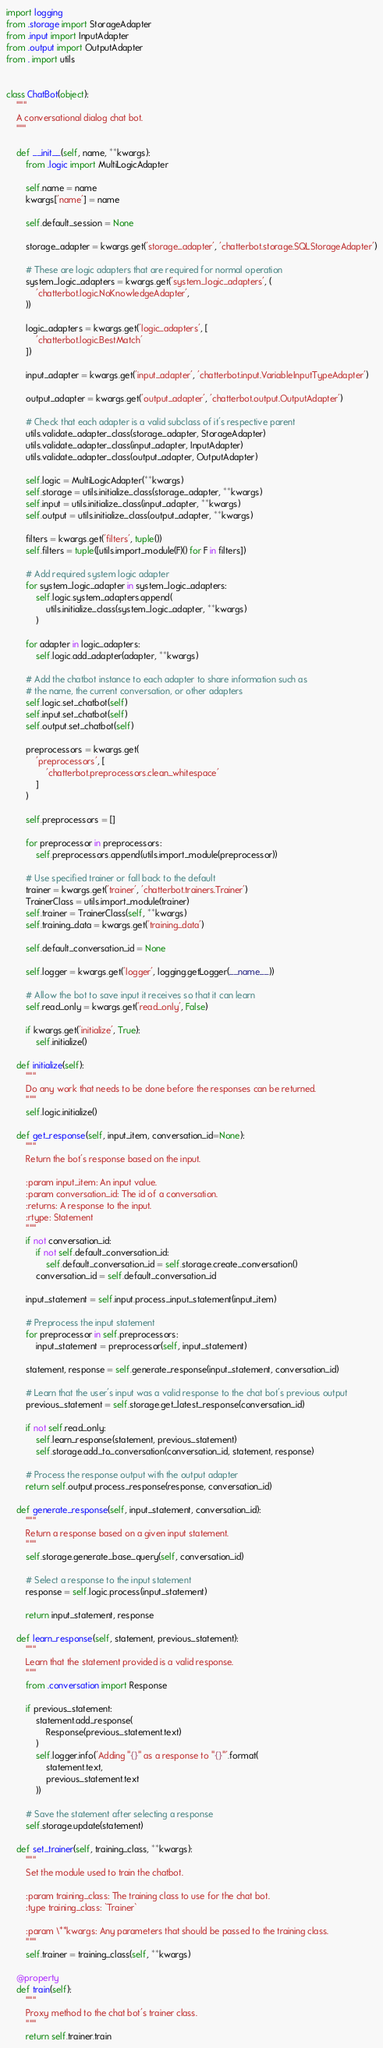Convert code to text. <code><loc_0><loc_0><loc_500><loc_500><_Python_>import logging
from .storage import StorageAdapter
from .input import InputAdapter
from .output import OutputAdapter
from . import utils


class ChatBot(object):
    """
    A conversational dialog chat bot.
    """

    def __init__(self, name, **kwargs):
        from .logic import MultiLogicAdapter

        self.name = name
        kwargs['name'] = name

        self.default_session = None

        storage_adapter = kwargs.get('storage_adapter', 'chatterbot.storage.SQLStorageAdapter')

        # These are logic adapters that are required for normal operation
        system_logic_adapters = kwargs.get('system_logic_adapters', (
            'chatterbot.logic.NoKnowledgeAdapter',
        ))

        logic_adapters = kwargs.get('logic_adapters', [
            'chatterbot.logic.BestMatch'
        ])

        input_adapter = kwargs.get('input_adapter', 'chatterbot.input.VariableInputTypeAdapter')

        output_adapter = kwargs.get('output_adapter', 'chatterbot.output.OutputAdapter')

        # Check that each adapter is a valid subclass of it's respective parent
        utils.validate_adapter_class(storage_adapter, StorageAdapter)
        utils.validate_adapter_class(input_adapter, InputAdapter)
        utils.validate_adapter_class(output_adapter, OutputAdapter)

        self.logic = MultiLogicAdapter(**kwargs)
        self.storage = utils.initialize_class(storage_adapter, **kwargs)
        self.input = utils.initialize_class(input_adapter, **kwargs)
        self.output = utils.initialize_class(output_adapter, **kwargs)

        filters = kwargs.get('filters', tuple())
        self.filters = tuple([utils.import_module(F)() for F in filters])

        # Add required system logic adapter
        for system_logic_adapter in system_logic_adapters:
            self.logic.system_adapters.append(
                utils.initialize_class(system_logic_adapter, **kwargs)
            )

        for adapter in logic_adapters:
            self.logic.add_adapter(adapter, **kwargs)

        # Add the chatbot instance to each adapter to share information such as
        # the name, the current conversation, or other adapters
        self.logic.set_chatbot(self)
        self.input.set_chatbot(self)
        self.output.set_chatbot(self)

        preprocessors = kwargs.get(
            'preprocessors', [
                'chatterbot.preprocessors.clean_whitespace'
            ]
        )

        self.preprocessors = []

        for preprocessor in preprocessors:
            self.preprocessors.append(utils.import_module(preprocessor))

        # Use specified trainer or fall back to the default
        trainer = kwargs.get('trainer', 'chatterbot.trainers.Trainer')
        TrainerClass = utils.import_module(trainer)
        self.trainer = TrainerClass(self, **kwargs)
        self.training_data = kwargs.get('training_data')

        self.default_conversation_id = None

        self.logger = kwargs.get('logger', logging.getLogger(__name__))

        # Allow the bot to save input it receives so that it can learn
        self.read_only = kwargs.get('read_only', False)

        if kwargs.get('initialize', True):
            self.initialize()

    def initialize(self):
        """
        Do any work that needs to be done before the responses can be returned.
        """
        self.logic.initialize()

    def get_response(self, input_item, conversation_id=None):
        """
        Return the bot's response based on the input.

        :param input_item: An input value.
        :param conversation_id: The id of a conversation.
        :returns: A response to the input.
        :rtype: Statement
        """
        if not conversation_id:
            if not self.default_conversation_id:
                self.default_conversation_id = self.storage.create_conversation()
            conversation_id = self.default_conversation_id

        input_statement = self.input.process_input_statement(input_item)

        # Preprocess the input statement
        for preprocessor in self.preprocessors:
            input_statement = preprocessor(self, input_statement)

        statement, response = self.generate_response(input_statement, conversation_id)

        # Learn that the user's input was a valid response to the chat bot's previous output
        previous_statement = self.storage.get_latest_response(conversation_id)

        if not self.read_only:
            self.learn_response(statement, previous_statement)
            self.storage.add_to_conversation(conversation_id, statement, response)

        # Process the response output with the output adapter
        return self.output.process_response(response, conversation_id)

    def generate_response(self, input_statement, conversation_id):
        """
        Return a response based on a given input statement.
        """
        self.storage.generate_base_query(self, conversation_id)

        # Select a response to the input statement
        response = self.logic.process(input_statement)

        return input_statement, response

    def learn_response(self, statement, previous_statement):
        """
        Learn that the statement provided is a valid response.
        """
        from .conversation import Response

        if previous_statement:
            statement.add_response(
                Response(previous_statement.text)
            )
            self.logger.info('Adding "{}" as a response to "{}"'.format(
                statement.text,
                previous_statement.text
            ))

        # Save the statement after selecting a response
        self.storage.update(statement)

    def set_trainer(self, training_class, **kwargs):
        """
        Set the module used to train the chatbot.

        :param training_class: The training class to use for the chat bot.
        :type training_class: `Trainer`

        :param \**kwargs: Any parameters that should be passed to the training class.
        """
        self.trainer = training_class(self, **kwargs)

    @property
    def train(self):
        """
        Proxy method to the chat bot's trainer class.
        """
        return self.trainer.train
</code> 